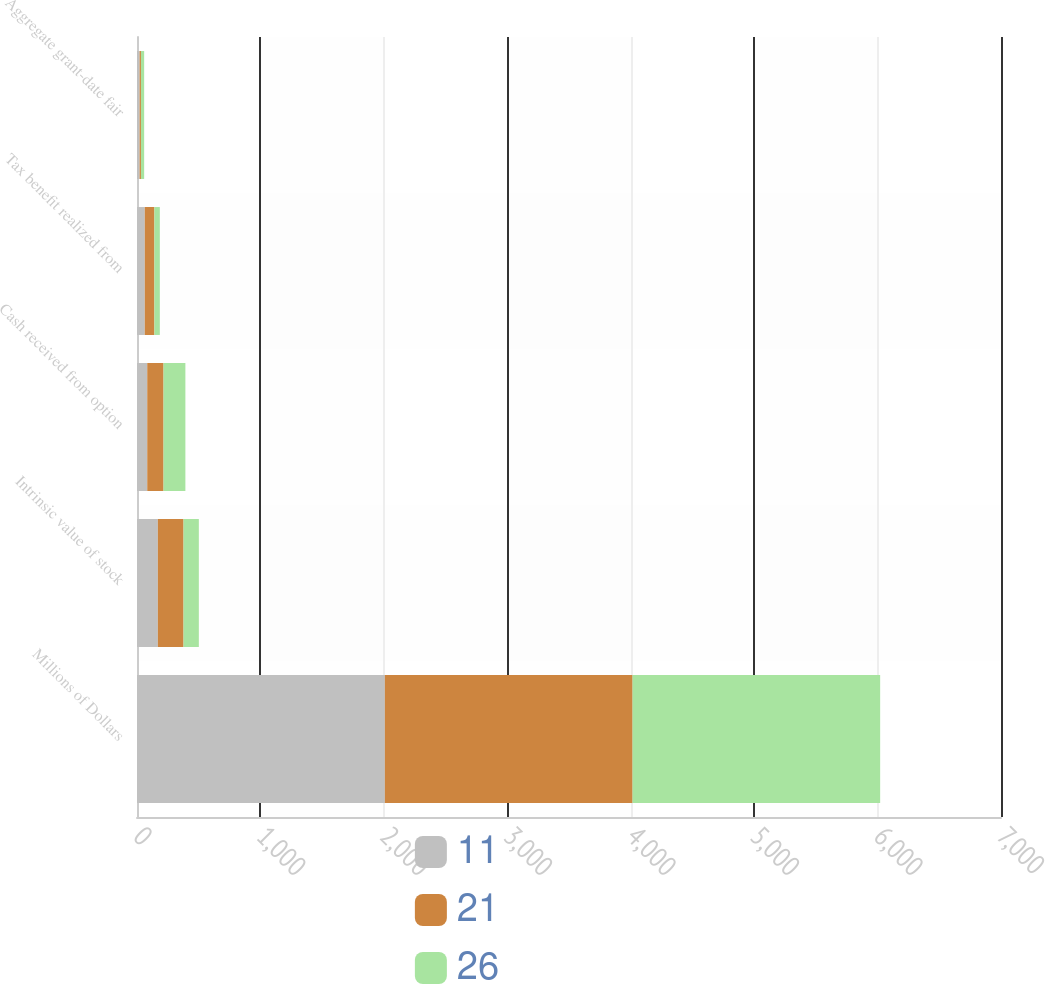Convert chart to OTSL. <chart><loc_0><loc_0><loc_500><loc_500><stacked_bar_chart><ecel><fcel>Millions of Dollars<fcel>Intrinsic value of stock<fcel>Cash received from option<fcel>Tax benefit realized from<fcel>Aggregate grant-date fair<nl><fcel>11<fcel>2008<fcel>169<fcel>83<fcel>63<fcel>21<nl><fcel>21<fcel>2007<fcel>208<fcel>132<fcel>78<fcel>11<nl><fcel>26<fcel>2006<fcel>124<fcel>177<fcel>44<fcel>26<nl></chart> 